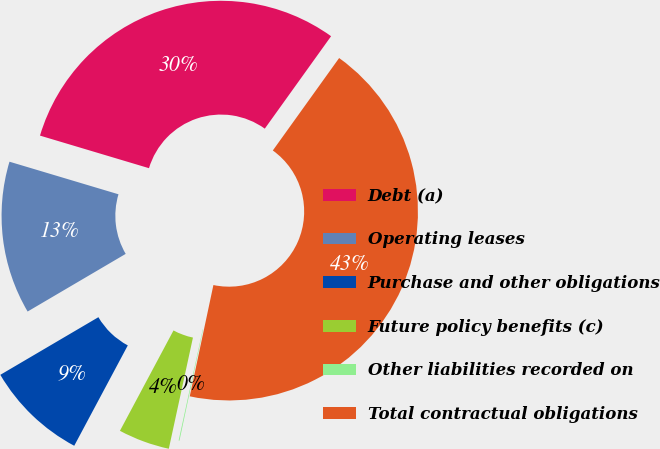<chart> <loc_0><loc_0><loc_500><loc_500><pie_chart><fcel>Debt (a)<fcel>Operating leases<fcel>Purchase and other obligations<fcel>Future policy benefits (c)<fcel>Other liabilities recorded on<fcel>Total contractual obligations<nl><fcel>30.28%<fcel>13.08%<fcel>8.74%<fcel>4.4%<fcel>0.07%<fcel>43.43%<nl></chart> 